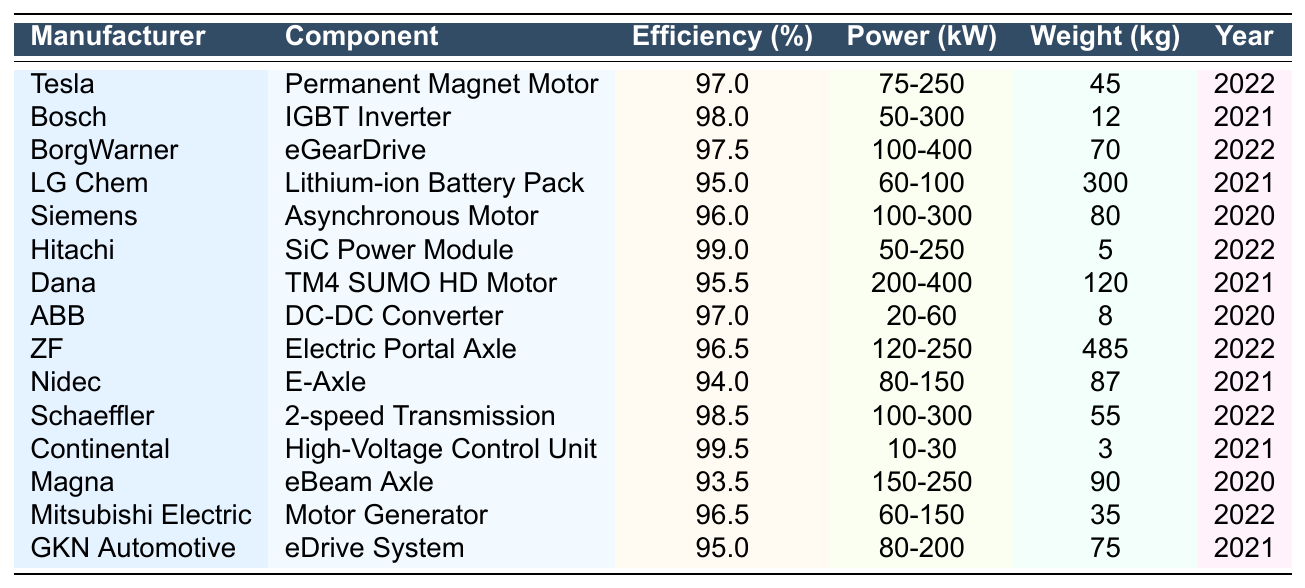What is the efficiency rating of the Bosch IGBT Inverter? According to the table, Bosch's IGBT Inverter has an efficiency rating of 98%.
Answer: 98% Which component has the highest efficiency rating? By looking at the efficiency ratings, the Continental High-Voltage Control Unit has the highest rating at 99.5%.
Answer: 99.5% Is the weight of the Hitachi SiC Power Module less than that of the LG Chem Lithium-ion Battery Pack? The weight of the Hitachi SiC Power Module is 5 kg, while the LG Chem Lithium-ion Battery Pack weighs 300 kg. Therefore, the statement is true.
Answer: Yes What is the average efficiency rating of the components manufactured in 2022? The efficiency ratings of the components from 2022 are 97 (Tesla), 97.5 (BorgWarner), 99 (Hitachi), 98.5 (Schaeffler), and 96.5 (Mitsubishi Electric). Summing these ratings gives 488, and dividing by 5 results in an average of 97.6%.
Answer: 97.6% Which manufacturer produces a motor with an efficiency rating of 95% or less? The table lists Magna's eBeam Axle with an efficiency rating of 93.5%, which is less than 95%.
Answer: Yes What is the combined power range in kW of the components from Bosch and ABB? Bosch's IGBT Inverter has a power range of 50-300 kW, and ABB's DC-DC Converter has a power range of 20-60 kW. The combined ranges result in a minimum of 50 kW and a maximum of 300 kW.
Answer: 50-300 kW How much heavier is the ZF Electric Portal Axle compared to the lightest component? The ZF Electric Portal Axle weighs 485 kg, and the lightest component, the Continental High-Voltage Control Unit, weighs 3 kg. The difference in weight is 485 - 3 = 482 kg.
Answer: 482 kg Which component has the largest power range? The data shows that the BorgWarner eGearDrive has the largest power range of 100-400 kW.
Answer: 100-400 kW Is there any other component, besides the Hitachi SiC Power Module, with an efficiency rating above 99%? Evaluating the table, the only component with an efficiency rating above 99% is the Continental High-Voltage Control Unit at 99.5%. Therefore, there are no others above 99%.
Answer: No What percentage of components weigh over 100 kg? Looking at the table, the components above 100 kg are the LG Chem Lithium-ion Battery Pack (300 kg), Dana TM4 SUMO HD Motor (120 kg), and ZF Electric Portal Axle (485 kg). That's 3 out of 15 components, which is 20%.
Answer: 20% 